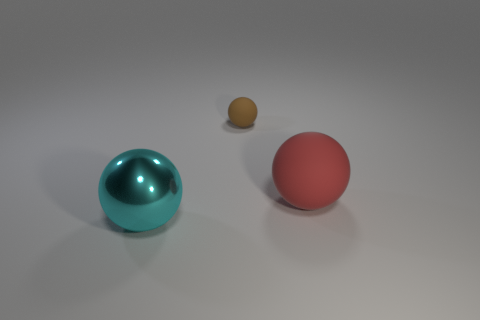Add 3 small purple metal balls. How many objects exist? 6 Add 2 large red spheres. How many large red spheres are left? 3 Add 3 green metal blocks. How many green metal blocks exist? 3 Subtract 0 blue spheres. How many objects are left? 3 Subtract all large rubber things. Subtract all red matte spheres. How many objects are left? 1 